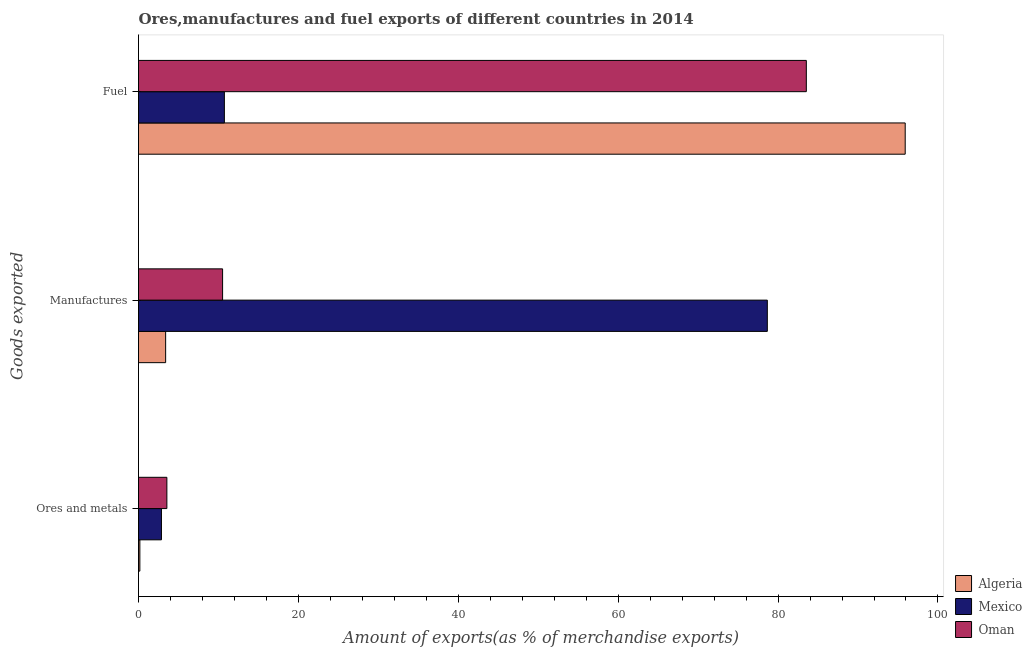How many groups of bars are there?
Offer a terse response. 3. Are the number of bars per tick equal to the number of legend labels?
Your answer should be compact. Yes. How many bars are there on the 1st tick from the top?
Provide a short and direct response. 3. How many bars are there on the 2nd tick from the bottom?
Offer a very short reply. 3. What is the label of the 3rd group of bars from the top?
Your answer should be very brief. Ores and metals. What is the percentage of ores and metals exports in Mexico?
Your answer should be very brief. 2.87. Across all countries, what is the maximum percentage of manufactures exports?
Offer a very short reply. 78.66. Across all countries, what is the minimum percentage of manufactures exports?
Offer a very short reply. 3.39. In which country was the percentage of ores and metals exports maximum?
Give a very brief answer. Oman. What is the total percentage of manufactures exports in the graph?
Give a very brief answer. 92.57. What is the difference between the percentage of fuel exports in Mexico and that in Algeria?
Offer a very short reply. -85.16. What is the difference between the percentage of ores and metals exports in Oman and the percentage of manufactures exports in Mexico?
Keep it short and to the point. -75.11. What is the average percentage of fuel exports per country?
Make the answer very short. 63.39. What is the difference between the percentage of fuel exports and percentage of manufactures exports in Oman?
Offer a terse response. 73.02. What is the ratio of the percentage of ores and metals exports in Algeria to that in Mexico?
Provide a succinct answer. 0.06. What is the difference between the highest and the second highest percentage of fuel exports?
Make the answer very short. 12.37. What is the difference between the highest and the lowest percentage of fuel exports?
Provide a succinct answer. 85.16. In how many countries, is the percentage of fuel exports greater than the average percentage of fuel exports taken over all countries?
Your answer should be very brief. 2. What does the 1st bar from the top in Manufactures represents?
Provide a short and direct response. Oman. What does the 3rd bar from the bottom in Ores and metals represents?
Your answer should be compact. Oman. Is it the case that in every country, the sum of the percentage of ores and metals exports and percentage of manufactures exports is greater than the percentage of fuel exports?
Keep it short and to the point. No. What is the difference between two consecutive major ticks on the X-axis?
Give a very brief answer. 20. Are the values on the major ticks of X-axis written in scientific E-notation?
Keep it short and to the point. No. Does the graph contain any zero values?
Give a very brief answer. No. Does the graph contain grids?
Your answer should be very brief. No. What is the title of the graph?
Provide a succinct answer. Ores,manufactures and fuel exports of different countries in 2014. Does "Cambodia" appear as one of the legend labels in the graph?
Your answer should be compact. No. What is the label or title of the X-axis?
Offer a terse response. Amount of exports(as % of merchandise exports). What is the label or title of the Y-axis?
Your answer should be very brief. Goods exported. What is the Amount of exports(as % of merchandise exports) in Algeria in Ores and metals?
Provide a succinct answer. 0.17. What is the Amount of exports(as % of merchandise exports) of Mexico in Ores and metals?
Offer a terse response. 2.87. What is the Amount of exports(as % of merchandise exports) of Oman in Ores and metals?
Provide a succinct answer. 3.55. What is the Amount of exports(as % of merchandise exports) in Algeria in Manufactures?
Give a very brief answer. 3.39. What is the Amount of exports(as % of merchandise exports) in Mexico in Manufactures?
Provide a succinct answer. 78.66. What is the Amount of exports(as % of merchandise exports) of Oman in Manufactures?
Keep it short and to the point. 10.52. What is the Amount of exports(as % of merchandise exports) in Algeria in Fuel?
Give a very brief answer. 95.9. What is the Amount of exports(as % of merchandise exports) in Mexico in Fuel?
Offer a very short reply. 10.74. What is the Amount of exports(as % of merchandise exports) in Oman in Fuel?
Provide a short and direct response. 83.53. Across all Goods exported, what is the maximum Amount of exports(as % of merchandise exports) in Algeria?
Your response must be concise. 95.9. Across all Goods exported, what is the maximum Amount of exports(as % of merchandise exports) of Mexico?
Your response must be concise. 78.66. Across all Goods exported, what is the maximum Amount of exports(as % of merchandise exports) of Oman?
Provide a succinct answer. 83.53. Across all Goods exported, what is the minimum Amount of exports(as % of merchandise exports) in Algeria?
Give a very brief answer. 0.17. Across all Goods exported, what is the minimum Amount of exports(as % of merchandise exports) in Mexico?
Give a very brief answer. 2.87. Across all Goods exported, what is the minimum Amount of exports(as % of merchandise exports) of Oman?
Keep it short and to the point. 3.55. What is the total Amount of exports(as % of merchandise exports) of Algeria in the graph?
Provide a short and direct response. 99.47. What is the total Amount of exports(as % of merchandise exports) in Mexico in the graph?
Make the answer very short. 92.27. What is the total Amount of exports(as % of merchandise exports) of Oman in the graph?
Your answer should be compact. 97.6. What is the difference between the Amount of exports(as % of merchandise exports) in Algeria in Ores and metals and that in Manufactures?
Provide a succinct answer. -3.23. What is the difference between the Amount of exports(as % of merchandise exports) of Mexico in Ores and metals and that in Manufactures?
Your response must be concise. -75.79. What is the difference between the Amount of exports(as % of merchandise exports) of Oman in Ores and metals and that in Manufactures?
Offer a terse response. -6.97. What is the difference between the Amount of exports(as % of merchandise exports) in Algeria in Ores and metals and that in Fuel?
Provide a succinct answer. -95.73. What is the difference between the Amount of exports(as % of merchandise exports) of Mexico in Ores and metals and that in Fuel?
Your answer should be very brief. -7.87. What is the difference between the Amount of exports(as % of merchandise exports) of Oman in Ores and metals and that in Fuel?
Ensure brevity in your answer.  -79.99. What is the difference between the Amount of exports(as % of merchandise exports) of Algeria in Manufactures and that in Fuel?
Give a very brief answer. -92.51. What is the difference between the Amount of exports(as % of merchandise exports) in Mexico in Manufactures and that in Fuel?
Keep it short and to the point. 67.92. What is the difference between the Amount of exports(as % of merchandise exports) in Oman in Manufactures and that in Fuel?
Offer a terse response. -73.02. What is the difference between the Amount of exports(as % of merchandise exports) of Algeria in Ores and metals and the Amount of exports(as % of merchandise exports) of Mexico in Manufactures?
Offer a terse response. -78.49. What is the difference between the Amount of exports(as % of merchandise exports) of Algeria in Ores and metals and the Amount of exports(as % of merchandise exports) of Oman in Manufactures?
Provide a succinct answer. -10.35. What is the difference between the Amount of exports(as % of merchandise exports) in Mexico in Ores and metals and the Amount of exports(as % of merchandise exports) in Oman in Manufactures?
Keep it short and to the point. -7.65. What is the difference between the Amount of exports(as % of merchandise exports) of Algeria in Ores and metals and the Amount of exports(as % of merchandise exports) of Mexico in Fuel?
Make the answer very short. -10.57. What is the difference between the Amount of exports(as % of merchandise exports) in Algeria in Ores and metals and the Amount of exports(as % of merchandise exports) in Oman in Fuel?
Offer a terse response. -83.36. What is the difference between the Amount of exports(as % of merchandise exports) of Mexico in Ores and metals and the Amount of exports(as % of merchandise exports) of Oman in Fuel?
Keep it short and to the point. -80.66. What is the difference between the Amount of exports(as % of merchandise exports) of Algeria in Manufactures and the Amount of exports(as % of merchandise exports) of Mexico in Fuel?
Provide a succinct answer. -7.35. What is the difference between the Amount of exports(as % of merchandise exports) in Algeria in Manufactures and the Amount of exports(as % of merchandise exports) in Oman in Fuel?
Make the answer very short. -80.14. What is the difference between the Amount of exports(as % of merchandise exports) in Mexico in Manufactures and the Amount of exports(as % of merchandise exports) in Oman in Fuel?
Provide a succinct answer. -4.88. What is the average Amount of exports(as % of merchandise exports) in Algeria per Goods exported?
Keep it short and to the point. 33.16. What is the average Amount of exports(as % of merchandise exports) of Mexico per Goods exported?
Offer a very short reply. 30.76. What is the average Amount of exports(as % of merchandise exports) in Oman per Goods exported?
Keep it short and to the point. 32.53. What is the difference between the Amount of exports(as % of merchandise exports) of Algeria and Amount of exports(as % of merchandise exports) of Mexico in Ores and metals?
Provide a succinct answer. -2.7. What is the difference between the Amount of exports(as % of merchandise exports) of Algeria and Amount of exports(as % of merchandise exports) of Oman in Ores and metals?
Give a very brief answer. -3.38. What is the difference between the Amount of exports(as % of merchandise exports) in Mexico and Amount of exports(as % of merchandise exports) in Oman in Ores and metals?
Your response must be concise. -0.68. What is the difference between the Amount of exports(as % of merchandise exports) in Algeria and Amount of exports(as % of merchandise exports) in Mexico in Manufactures?
Your answer should be very brief. -75.26. What is the difference between the Amount of exports(as % of merchandise exports) in Algeria and Amount of exports(as % of merchandise exports) in Oman in Manufactures?
Ensure brevity in your answer.  -7.12. What is the difference between the Amount of exports(as % of merchandise exports) of Mexico and Amount of exports(as % of merchandise exports) of Oman in Manufactures?
Your answer should be very brief. 68.14. What is the difference between the Amount of exports(as % of merchandise exports) in Algeria and Amount of exports(as % of merchandise exports) in Mexico in Fuel?
Give a very brief answer. 85.16. What is the difference between the Amount of exports(as % of merchandise exports) in Algeria and Amount of exports(as % of merchandise exports) in Oman in Fuel?
Offer a very short reply. 12.37. What is the difference between the Amount of exports(as % of merchandise exports) in Mexico and Amount of exports(as % of merchandise exports) in Oman in Fuel?
Make the answer very short. -72.79. What is the ratio of the Amount of exports(as % of merchandise exports) of Algeria in Ores and metals to that in Manufactures?
Your response must be concise. 0.05. What is the ratio of the Amount of exports(as % of merchandise exports) of Mexico in Ores and metals to that in Manufactures?
Your response must be concise. 0.04. What is the ratio of the Amount of exports(as % of merchandise exports) of Oman in Ores and metals to that in Manufactures?
Ensure brevity in your answer.  0.34. What is the ratio of the Amount of exports(as % of merchandise exports) in Algeria in Ores and metals to that in Fuel?
Your answer should be compact. 0. What is the ratio of the Amount of exports(as % of merchandise exports) of Mexico in Ores and metals to that in Fuel?
Ensure brevity in your answer.  0.27. What is the ratio of the Amount of exports(as % of merchandise exports) in Oman in Ores and metals to that in Fuel?
Give a very brief answer. 0.04. What is the ratio of the Amount of exports(as % of merchandise exports) of Algeria in Manufactures to that in Fuel?
Your answer should be very brief. 0.04. What is the ratio of the Amount of exports(as % of merchandise exports) in Mexico in Manufactures to that in Fuel?
Offer a terse response. 7.32. What is the ratio of the Amount of exports(as % of merchandise exports) in Oman in Manufactures to that in Fuel?
Your answer should be compact. 0.13. What is the difference between the highest and the second highest Amount of exports(as % of merchandise exports) in Algeria?
Ensure brevity in your answer.  92.51. What is the difference between the highest and the second highest Amount of exports(as % of merchandise exports) in Mexico?
Give a very brief answer. 67.92. What is the difference between the highest and the second highest Amount of exports(as % of merchandise exports) of Oman?
Provide a succinct answer. 73.02. What is the difference between the highest and the lowest Amount of exports(as % of merchandise exports) in Algeria?
Keep it short and to the point. 95.73. What is the difference between the highest and the lowest Amount of exports(as % of merchandise exports) in Mexico?
Give a very brief answer. 75.79. What is the difference between the highest and the lowest Amount of exports(as % of merchandise exports) in Oman?
Ensure brevity in your answer.  79.99. 